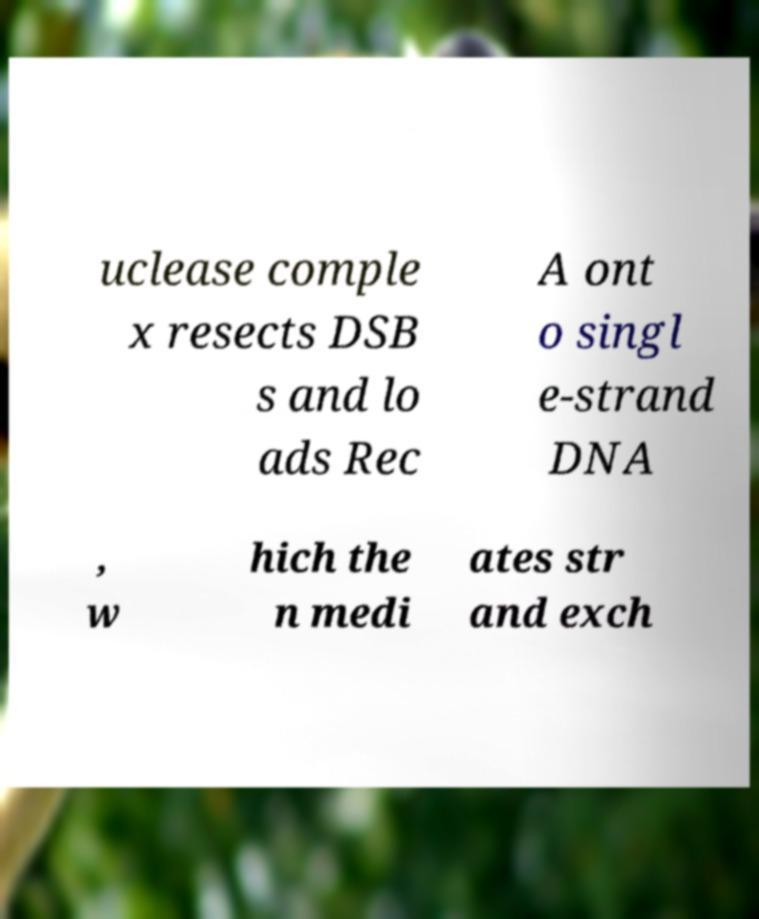Can you read and provide the text displayed in the image?This photo seems to have some interesting text. Can you extract and type it out for me? uclease comple x resects DSB s and lo ads Rec A ont o singl e-strand DNA , w hich the n medi ates str and exch 